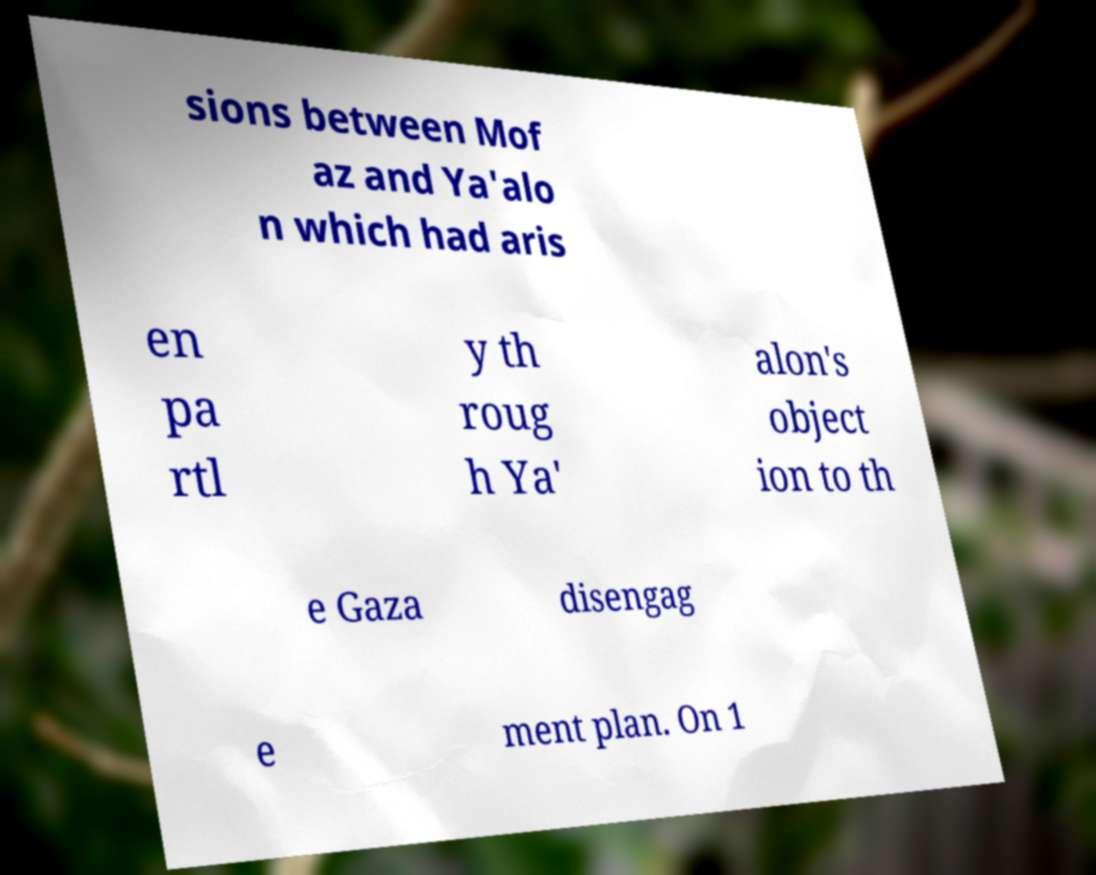For documentation purposes, I need the text within this image transcribed. Could you provide that? sions between Mof az and Ya'alo n which had aris en pa rtl y th roug h Ya' alon's object ion to th e Gaza disengag e ment plan. On 1 